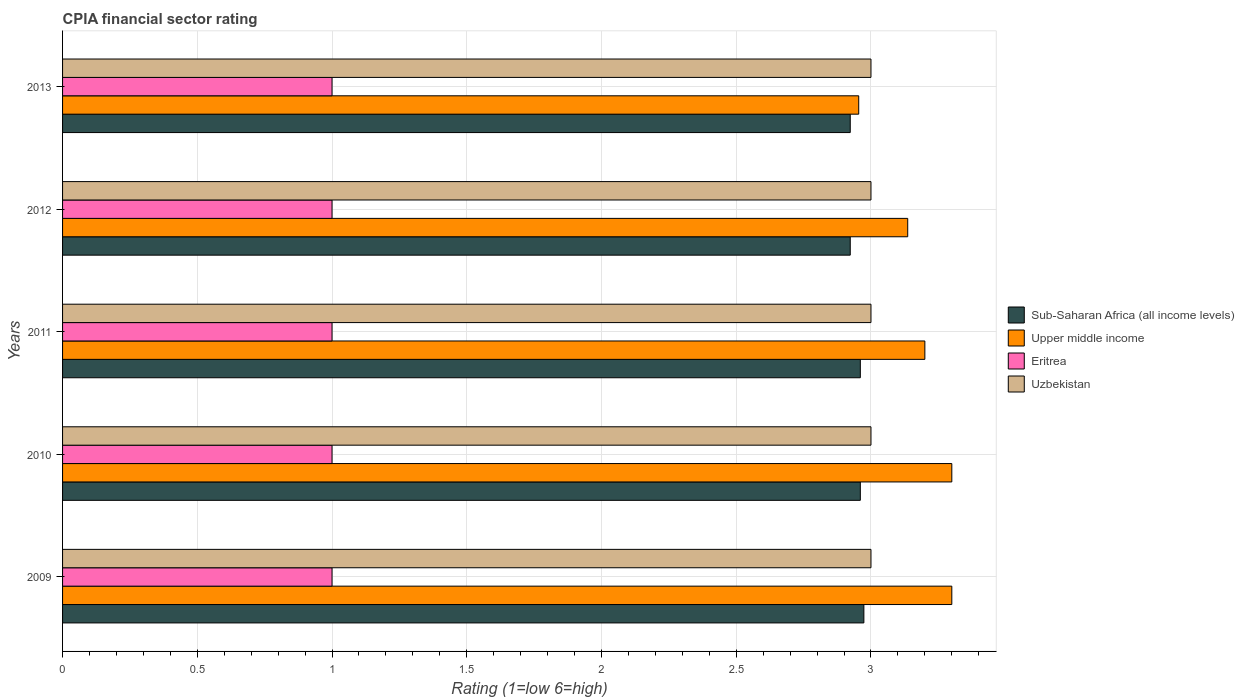How many different coloured bars are there?
Provide a short and direct response. 4. Are the number of bars per tick equal to the number of legend labels?
Keep it short and to the point. Yes. How many bars are there on the 3rd tick from the bottom?
Provide a succinct answer. 4. What is the CPIA rating in Eritrea in 2009?
Provide a short and direct response. 1. Across all years, what is the minimum CPIA rating in Sub-Saharan Africa (all income levels)?
Give a very brief answer. 2.92. In which year was the CPIA rating in Eritrea maximum?
Your answer should be compact. 2009. In which year was the CPIA rating in Uzbekistan minimum?
Offer a terse response. 2009. What is the total CPIA rating in Upper middle income in the graph?
Ensure brevity in your answer.  15.89. What is the difference between the CPIA rating in Uzbekistan in 2009 and the CPIA rating in Upper middle income in 2012?
Offer a terse response. -0.14. In the year 2010, what is the difference between the CPIA rating in Upper middle income and CPIA rating in Eritrea?
Provide a succinct answer. 2.3. In how many years, is the CPIA rating in Uzbekistan greater than 2.7 ?
Your answer should be very brief. 5. What is the ratio of the CPIA rating in Uzbekistan in 2010 to that in 2013?
Ensure brevity in your answer.  1. What is the difference between the highest and the second highest CPIA rating in Eritrea?
Keep it short and to the point. 0. In how many years, is the CPIA rating in Eritrea greater than the average CPIA rating in Eritrea taken over all years?
Make the answer very short. 0. Is the sum of the CPIA rating in Uzbekistan in 2011 and 2012 greater than the maximum CPIA rating in Eritrea across all years?
Offer a terse response. Yes. Is it the case that in every year, the sum of the CPIA rating in Eritrea and CPIA rating in Sub-Saharan Africa (all income levels) is greater than the sum of CPIA rating in Upper middle income and CPIA rating in Uzbekistan?
Your answer should be compact. Yes. What does the 4th bar from the top in 2013 represents?
Keep it short and to the point. Sub-Saharan Africa (all income levels). What does the 3rd bar from the bottom in 2010 represents?
Ensure brevity in your answer.  Eritrea. Are all the bars in the graph horizontal?
Provide a short and direct response. Yes. How many years are there in the graph?
Offer a terse response. 5. What is the difference between two consecutive major ticks on the X-axis?
Your response must be concise. 0.5. Are the values on the major ticks of X-axis written in scientific E-notation?
Provide a short and direct response. No. Does the graph contain any zero values?
Offer a terse response. No. Does the graph contain grids?
Your answer should be compact. Yes. What is the title of the graph?
Offer a terse response. CPIA financial sector rating. Does "Botswana" appear as one of the legend labels in the graph?
Make the answer very short. No. What is the label or title of the X-axis?
Provide a succinct answer. Rating (1=low 6=high). What is the label or title of the Y-axis?
Your answer should be very brief. Years. What is the Rating (1=low 6=high) in Sub-Saharan Africa (all income levels) in 2009?
Offer a very short reply. 2.97. What is the Rating (1=low 6=high) in Uzbekistan in 2009?
Your answer should be very brief. 3. What is the Rating (1=low 6=high) of Sub-Saharan Africa (all income levels) in 2010?
Give a very brief answer. 2.96. What is the Rating (1=low 6=high) in Upper middle income in 2010?
Keep it short and to the point. 3.3. What is the Rating (1=low 6=high) in Sub-Saharan Africa (all income levels) in 2011?
Offer a very short reply. 2.96. What is the Rating (1=low 6=high) of Upper middle income in 2011?
Provide a succinct answer. 3.2. What is the Rating (1=low 6=high) of Uzbekistan in 2011?
Ensure brevity in your answer.  3. What is the Rating (1=low 6=high) of Sub-Saharan Africa (all income levels) in 2012?
Offer a very short reply. 2.92. What is the Rating (1=low 6=high) of Upper middle income in 2012?
Ensure brevity in your answer.  3.14. What is the Rating (1=low 6=high) in Uzbekistan in 2012?
Keep it short and to the point. 3. What is the Rating (1=low 6=high) in Sub-Saharan Africa (all income levels) in 2013?
Give a very brief answer. 2.92. What is the Rating (1=low 6=high) in Upper middle income in 2013?
Offer a terse response. 2.95. What is the Rating (1=low 6=high) in Uzbekistan in 2013?
Give a very brief answer. 3. Across all years, what is the maximum Rating (1=low 6=high) of Sub-Saharan Africa (all income levels)?
Offer a terse response. 2.97. Across all years, what is the minimum Rating (1=low 6=high) in Sub-Saharan Africa (all income levels)?
Offer a very short reply. 2.92. Across all years, what is the minimum Rating (1=low 6=high) in Upper middle income?
Provide a short and direct response. 2.95. Across all years, what is the minimum Rating (1=low 6=high) in Eritrea?
Ensure brevity in your answer.  1. What is the total Rating (1=low 6=high) in Sub-Saharan Africa (all income levels) in the graph?
Your response must be concise. 14.74. What is the total Rating (1=low 6=high) of Upper middle income in the graph?
Keep it short and to the point. 15.89. What is the total Rating (1=low 6=high) of Uzbekistan in the graph?
Your answer should be very brief. 15. What is the difference between the Rating (1=low 6=high) in Sub-Saharan Africa (all income levels) in 2009 and that in 2010?
Give a very brief answer. 0.01. What is the difference between the Rating (1=low 6=high) of Upper middle income in 2009 and that in 2010?
Offer a terse response. 0. What is the difference between the Rating (1=low 6=high) in Eritrea in 2009 and that in 2010?
Offer a very short reply. 0. What is the difference between the Rating (1=low 6=high) in Sub-Saharan Africa (all income levels) in 2009 and that in 2011?
Make the answer very short. 0.01. What is the difference between the Rating (1=low 6=high) of Upper middle income in 2009 and that in 2011?
Ensure brevity in your answer.  0.1. What is the difference between the Rating (1=low 6=high) in Eritrea in 2009 and that in 2011?
Your answer should be compact. 0. What is the difference between the Rating (1=low 6=high) of Uzbekistan in 2009 and that in 2011?
Your response must be concise. 0. What is the difference between the Rating (1=low 6=high) in Sub-Saharan Africa (all income levels) in 2009 and that in 2012?
Offer a very short reply. 0.05. What is the difference between the Rating (1=low 6=high) of Upper middle income in 2009 and that in 2012?
Your answer should be very brief. 0.16. What is the difference between the Rating (1=low 6=high) of Uzbekistan in 2009 and that in 2012?
Your answer should be compact. 0. What is the difference between the Rating (1=low 6=high) in Sub-Saharan Africa (all income levels) in 2009 and that in 2013?
Keep it short and to the point. 0.05. What is the difference between the Rating (1=low 6=high) in Upper middle income in 2009 and that in 2013?
Ensure brevity in your answer.  0.35. What is the difference between the Rating (1=low 6=high) in Eritrea in 2009 and that in 2013?
Give a very brief answer. 0. What is the difference between the Rating (1=low 6=high) in Uzbekistan in 2009 and that in 2013?
Ensure brevity in your answer.  0. What is the difference between the Rating (1=low 6=high) of Upper middle income in 2010 and that in 2011?
Offer a very short reply. 0.1. What is the difference between the Rating (1=low 6=high) in Sub-Saharan Africa (all income levels) in 2010 and that in 2012?
Make the answer very short. 0.04. What is the difference between the Rating (1=low 6=high) of Upper middle income in 2010 and that in 2012?
Your answer should be compact. 0.16. What is the difference between the Rating (1=low 6=high) of Eritrea in 2010 and that in 2012?
Make the answer very short. 0. What is the difference between the Rating (1=low 6=high) in Sub-Saharan Africa (all income levels) in 2010 and that in 2013?
Your answer should be very brief. 0.04. What is the difference between the Rating (1=low 6=high) in Upper middle income in 2010 and that in 2013?
Ensure brevity in your answer.  0.35. What is the difference between the Rating (1=low 6=high) in Eritrea in 2010 and that in 2013?
Your response must be concise. 0. What is the difference between the Rating (1=low 6=high) in Sub-Saharan Africa (all income levels) in 2011 and that in 2012?
Keep it short and to the point. 0.04. What is the difference between the Rating (1=low 6=high) in Upper middle income in 2011 and that in 2012?
Offer a very short reply. 0.06. What is the difference between the Rating (1=low 6=high) of Eritrea in 2011 and that in 2012?
Provide a short and direct response. 0. What is the difference between the Rating (1=low 6=high) of Uzbekistan in 2011 and that in 2012?
Your response must be concise. 0. What is the difference between the Rating (1=low 6=high) in Sub-Saharan Africa (all income levels) in 2011 and that in 2013?
Offer a very short reply. 0.04. What is the difference between the Rating (1=low 6=high) of Upper middle income in 2011 and that in 2013?
Give a very brief answer. 0.25. What is the difference between the Rating (1=low 6=high) of Eritrea in 2011 and that in 2013?
Offer a terse response. 0. What is the difference between the Rating (1=low 6=high) in Uzbekistan in 2011 and that in 2013?
Give a very brief answer. 0. What is the difference between the Rating (1=low 6=high) of Sub-Saharan Africa (all income levels) in 2012 and that in 2013?
Offer a terse response. 0. What is the difference between the Rating (1=low 6=high) of Upper middle income in 2012 and that in 2013?
Your answer should be compact. 0.18. What is the difference between the Rating (1=low 6=high) of Eritrea in 2012 and that in 2013?
Offer a terse response. 0. What is the difference between the Rating (1=low 6=high) of Sub-Saharan Africa (all income levels) in 2009 and the Rating (1=low 6=high) of Upper middle income in 2010?
Make the answer very short. -0.33. What is the difference between the Rating (1=low 6=high) in Sub-Saharan Africa (all income levels) in 2009 and the Rating (1=low 6=high) in Eritrea in 2010?
Keep it short and to the point. 1.97. What is the difference between the Rating (1=low 6=high) in Sub-Saharan Africa (all income levels) in 2009 and the Rating (1=low 6=high) in Uzbekistan in 2010?
Give a very brief answer. -0.03. What is the difference between the Rating (1=low 6=high) in Sub-Saharan Africa (all income levels) in 2009 and the Rating (1=low 6=high) in Upper middle income in 2011?
Your response must be concise. -0.23. What is the difference between the Rating (1=low 6=high) of Sub-Saharan Africa (all income levels) in 2009 and the Rating (1=low 6=high) of Eritrea in 2011?
Offer a terse response. 1.97. What is the difference between the Rating (1=low 6=high) in Sub-Saharan Africa (all income levels) in 2009 and the Rating (1=low 6=high) in Uzbekistan in 2011?
Make the answer very short. -0.03. What is the difference between the Rating (1=low 6=high) in Upper middle income in 2009 and the Rating (1=low 6=high) in Eritrea in 2011?
Offer a very short reply. 2.3. What is the difference between the Rating (1=low 6=high) of Sub-Saharan Africa (all income levels) in 2009 and the Rating (1=low 6=high) of Upper middle income in 2012?
Your answer should be compact. -0.16. What is the difference between the Rating (1=low 6=high) in Sub-Saharan Africa (all income levels) in 2009 and the Rating (1=low 6=high) in Eritrea in 2012?
Your answer should be very brief. 1.97. What is the difference between the Rating (1=low 6=high) in Sub-Saharan Africa (all income levels) in 2009 and the Rating (1=low 6=high) in Uzbekistan in 2012?
Your answer should be very brief. -0.03. What is the difference between the Rating (1=low 6=high) in Eritrea in 2009 and the Rating (1=low 6=high) in Uzbekistan in 2012?
Give a very brief answer. -2. What is the difference between the Rating (1=low 6=high) of Sub-Saharan Africa (all income levels) in 2009 and the Rating (1=low 6=high) of Upper middle income in 2013?
Your answer should be very brief. 0.02. What is the difference between the Rating (1=low 6=high) in Sub-Saharan Africa (all income levels) in 2009 and the Rating (1=low 6=high) in Eritrea in 2013?
Your answer should be very brief. 1.97. What is the difference between the Rating (1=low 6=high) in Sub-Saharan Africa (all income levels) in 2009 and the Rating (1=low 6=high) in Uzbekistan in 2013?
Keep it short and to the point. -0.03. What is the difference between the Rating (1=low 6=high) of Upper middle income in 2009 and the Rating (1=low 6=high) of Uzbekistan in 2013?
Your response must be concise. 0.3. What is the difference between the Rating (1=low 6=high) in Eritrea in 2009 and the Rating (1=low 6=high) in Uzbekistan in 2013?
Provide a short and direct response. -2. What is the difference between the Rating (1=low 6=high) in Sub-Saharan Africa (all income levels) in 2010 and the Rating (1=low 6=high) in Upper middle income in 2011?
Give a very brief answer. -0.24. What is the difference between the Rating (1=low 6=high) of Sub-Saharan Africa (all income levels) in 2010 and the Rating (1=low 6=high) of Eritrea in 2011?
Your answer should be compact. 1.96. What is the difference between the Rating (1=low 6=high) in Sub-Saharan Africa (all income levels) in 2010 and the Rating (1=low 6=high) in Uzbekistan in 2011?
Provide a succinct answer. -0.04. What is the difference between the Rating (1=low 6=high) in Sub-Saharan Africa (all income levels) in 2010 and the Rating (1=low 6=high) in Upper middle income in 2012?
Provide a succinct answer. -0.18. What is the difference between the Rating (1=low 6=high) of Sub-Saharan Africa (all income levels) in 2010 and the Rating (1=low 6=high) of Eritrea in 2012?
Your answer should be compact. 1.96. What is the difference between the Rating (1=low 6=high) of Sub-Saharan Africa (all income levels) in 2010 and the Rating (1=low 6=high) of Uzbekistan in 2012?
Provide a succinct answer. -0.04. What is the difference between the Rating (1=low 6=high) in Upper middle income in 2010 and the Rating (1=low 6=high) in Eritrea in 2012?
Keep it short and to the point. 2.3. What is the difference between the Rating (1=low 6=high) in Upper middle income in 2010 and the Rating (1=low 6=high) in Uzbekistan in 2012?
Offer a terse response. 0.3. What is the difference between the Rating (1=low 6=high) of Eritrea in 2010 and the Rating (1=low 6=high) of Uzbekistan in 2012?
Keep it short and to the point. -2. What is the difference between the Rating (1=low 6=high) in Sub-Saharan Africa (all income levels) in 2010 and the Rating (1=low 6=high) in Upper middle income in 2013?
Provide a short and direct response. 0.01. What is the difference between the Rating (1=low 6=high) in Sub-Saharan Africa (all income levels) in 2010 and the Rating (1=low 6=high) in Eritrea in 2013?
Your response must be concise. 1.96. What is the difference between the Rating (1=low 6=high) in Sub-Saharan Africa (all income levels) in 2010 and the Rating (1=low 6=high) in Uzbekistan in 2013?
Your answer should be very brief. -0.04. What is the difference between the Rating (1=low 6=high) in Upper middle income in 2010 and the Rating (1=low 6=high) in Eritrea in 2013?
Give a very brief answer. 2.3. What is the difference between the Rating (1=low 6=high) of Eritrea in 2010 and the Rating (1=low 6=high) of Uzbekistan in 2013?
Ensure brevity in your answer.  -2. What is the difference between the Rating (1=low 6=high) in Sub-Saharan Africa (all income levels) in 2011 and the Rating (1=low 6=high) in Upper middle income in 2012?
Keep it short and to the point. -0.18. What is the difference between the Rating (1=low 6=high) of Sub-Saharan Africa (all income levels) in 2011 and the Rating (1=low 6=high) of Eritrea in 2012?
Give a very brief answer. 1.96. What is the difference between the Rating (1=low 6=high) in Sub-Saharan Africa (all income levels) in 2011 and the Rating (1=low 6=high) in Uzbekistan in 2012?
Keep it short and to the point. -0.04. What is the difference between the Rating (1=low 6=high) in Upper middle income in 2011 and the Rating (1=low 6=high) in Eritrea in 2012?
Give a very brief answer. 2.2. What is the difference between the Rating (1=low 6=high) of Upper middle income in 2011 and the Rating (1=low 6=high) of Uzbekistan in 2012?
Provide a succinct answer. 0.2. What is the difference between the Rating (1=low 6=high) in Sub-Saharan Africa (all income levels) in 2011 and the Rating (1=low 6=high) in Upper middle income in 2013?
Provide a succinct answer. 0.01. What is the difference between the Rating (1=low 6=high) in Sub-Saharan Africa (all income levels) in 2011 and the Rating (1=low 6=high) in Eritrea in 2013?
Your answer should be compact. 1.96. What is the difference between the Rating (1=low 6=high) in Sub-Saharan Africa (all income levels) in 2011 and the Rating (1=low 6=high) in Uzbekistan in 2013?
Make the answer very short. -0.04. What is the difference between the Rating (1=low 6=high) of Sub-Saharan Africa (all income levels) in 2012 and the Rating (1=low 6=high) of Upper middle income in 2013?
Keep it short and to the point. -0.03. What is the difference between the Rating (1=low 6=high) in Sub-Saharan Africa (all income levels) in 2012 and the Rating (1=low 6=high) in Eritrea in 2013?
Your answer should be compact. 1.92. What is the difference between the Rating (1=low 6=high) of Sub-Saharan Africa (all income levels) in 2012 and the Rating (1=low 6=high) of Uzbekistan in 2013?
Provide a short and direct response. -0.08. What is the difference between the Rating (1=low 6=high) in Upper middle income in 2012 and the Rating (1=low 6=high) in Eritrea in 2013?
Your response must be concise. 2.14. What is the difference between the Rating (1=low 6=high) of Upper middle income in 2012 and the Rating (1=low 6=high) of Uzbekistan in 2013?
Offer a terse response. 0.14. What is the difference between the Rating (1=low 6=high) in Eritrea in 2012 and the Rating (1=low 6=high) in Uzbekistan in 2013?
Your answer should be very brief. -2. What is the average Rating (1=low 6=high) in Sub-Saharan Africa (all income levels) per year?
Ensure brevity in your answer.  2.95. What is the average Rating (1=low 6=high) in Upper middle income per year?
Keep it short and to the point. 3.18. What is the average Rating (1=low 6=high) of Eritrea per year?
Your response must be concise. 1. In the year 2009, what is the difference between the Rating (1=low 6=high) of Sub-Saharan Africa (all income levels) and Rating (1=low 6=high) of Upper middle income?
Make the answer very short. -0.33. In the year 2009, what is the difference between the Rating (1=low 6=high) in Sub-Saharan Africa (all income levels) and Rating (1=low 6=high) in Eritrea?
Make the answer very short. 1.97. In the year 2009, what is the difference between the Rating (1=low 6=high) in Sub-Saharan Africa (all income levels) and Rating (1=low 6=high) in Uzbekistan?
Offer a very short reply. -0.03. In the year 2010, what is the difference between the Rating (1=low 6=high) of Sub-Saharan Africa (all income levels) and Rating (1=low 6=high) of Upper middle income?
Provide a short and direct response. -0.34. In the year 2010, what is the difference between the Rating (1=low 6=high) in Sub-Saharan Africa (all income levels) and Rating (1=low 6=high) in Eritrea?
Keep it short and to the point. 1.96. In the year 2010, what is the difference between the Rating (1=low 6=high) of Sub-Saharan Africa (all income levels) and Rating (1=low 6=high) of Uzbekistan?
Give a very brief answer. -0.04. In the year 2010, what is the difference between the Rating (1=low 6=high) in Upper middle income and Rating (1=low 6=high) in Uzbekistan?
Your answer should be compact. 0.3. In the year 2010, what is the difference between the Rating (1=low 6=high) in Eritrea and Rating (1=low 6=high) in Uzbekistan?
Your response must be concise. -2. In the year 2011, what is the difference between the Rating (1=low 6=high) in Sub-Saharan Africa (all income levels) and Rating (1=low 6=high) in Upper middle income?
Offer a very short reply. -0.24. In the year 2011, what is the difference between the Rating (1=low 6=high) of Sub-Saharan Africa (all income levels) and Rating (1=low 6=high) of Eritrea?
Make the answer very short. 1.96. In the year 2011, what is the difference between the Rating (1=low 6=high) of Sub-Saharan Africa (all income levels) and Rating (1=low 6=high) of Uzbekistan?
Give a very brief answer. -0.04. In the year 2011, what is the difference between the Rating (1=low 6=high) in Upper middle income and Rating (1=low 6=high) in Uzbekistan?
Provide a succinct answer. 0.2. In the year 2011, what is the difference between the Rating (1=low 6=high) of Eritrea and Rating (1=low 6=high) of Uzbekistan?
Your response must be concise. -2. In the year 2012, what is the difference between the Rating (1=low 6=high) in Sub-Saharan Africa (all income levels) and Rating (1=low 6=high) in Upper middle income?
Offer a very short reply. -0.21. In the year 2012, what is the difference between the Rating (1=low 6=high) of Sub-Saharan Africa (all income levels) and Rating (1=low 6=high) of Eritrea?
Your answer should be compact. 1.92. In the year 2012, what is the difference between the Rating (1=low 6=high) of Sub-Saharan Africa (all income levels) and Rating (1=low 6=high) of Uzbekistan?
Provide a short and direct response. -0.08. In the year 2012, what is the difference between the Rating (1=low 6=high) of Upper middle income and Rating (1=low 6=high) of Eritrea?
Give a very brief answer. 2.14. In the year 2012, what is the difference between the Rating (1=low 6=high) of Upper middle income and Rating (1=low 6=high) of Uzbekistan?
Your answer should be very brief. 0.14. In the year 2012, what is the difference between the Rating (1=low 6=high) in Eritrea and Rating (1=low 6=high) in Uzbekistan?
Provide a succinct answer. -2. In the year 2013, what is the difference between the Rating (1=low 6=high) in Sub-Saharan Africa (all income levels) and Rating (1=low 6=high) in Upper middle income?
Make the answer very short. -0.03. In the year 2013, what is the difference between the Rating (1=low 6=high) in Sub-Saharan Africa (all income levels) and Rating (1=low 6=high) in Eritrea?
Your answer should be very brief. 1.92. In the year 2013, what is the difference between the Rating (1=low 6=high) in Sub-Saharan Africa (all income levels) and Rating (1=low 6=high) in Uzbekistan?
Ensure brevity in your answer.  -0.08. In the year 2013, what is the difference between the Rating (1=low 6=high) of Upper middle income and Rating (1=low 6=high) of Eritrea?
Ensure brevity in your answer.  1.95. In the year 2013, what is the difference between the Rating (1=low 6=high) of Upper middle income and Rating (1=low 6=high) of Uzbekistan?
Your answer should be compact. -0.05. What is the ratio of the Rating (1=low 6=high) in Eritrea in 2009 to that in 2010?
Your response must be concise. 1. What is the ratio of the Rating (1=low 6=high) in Upper middle income in 2009 to that in 2011?
Provide a short and direct response. 1.03. What is the ratio of the Rating (1=low 6=high) in Sub-Saharan Africa (all income levels) in 2009 to that in 2012?
Ensure brevity in your answer.  1.02. What is the ratio of the Rating (1=low 6=high) in Upper middle income in 2009 to that in 2012?
Your answer should be very brief. 1.05. What is the ratio of the Rating (1=low 6=high) of Uzbekistan in 2009 to that in 2012?
Make the answer very short. 1. What is the ratio of the Rating (1=low 6=high) of Sub-Saharan Africa (all income levels) in 2009 to that in 2013?
Make the answer very short. 1.02. What is the ratio of the Rating (1=low 6=high) in Upper middle income in 2009 to that in 2013?
Keep it short and to the point. 1.12. What is the ratio of the Rating (1=low 6=high) of Sub-Saharan Africa (all income levels) in 2010 to that in 2011?
Your response must be concise. 1. What is the ratio of the Rating (1=low 6=high) of Upper middle income in 2010 to that in 2011?
Give a very brief answer. 1.03. What is the ratio of the Rating (1=low 6=high) of Eritrea in 2010 to that in 2011?
Provide a short and direct response. 1. What is the ratio of the Rating (1=low 6=high) of Sub-Saharan Africa (all income levels) in 2010 to that in 2012?
Offer a terse response. 1.01. What is the ratio of the Rating (1=low 6=high) in Upper middle income in 2010 to that in 2012?
Make the answer very short. 1.05. What is the ratio of the Rating (1=low 6=high) of Uzbekistan in 2010 to that in 2012?
Your answer should be very brief. 1. What is the ratio of the Rating (1=low 6=high) of Sub-Saharan Africa (all income levels) in 2010 to that in 2013?
Keep it short and to the point. 1.01. What is the ratio of the Rating (1=low 6=high) in Upper middle income in 2010 to that in 2013?
Your answer should be compact. 1.12. What is the ratio of the Rating (1=low 6=high) in Eritrea in 2010 to that in 2013?
Your response must be concise. 1. What is the ratio of the Rating (1=low 6=high) in Uzbekistan in 2010 to that in 2013?
Your answer should be very brief. 1. What is the ratio of the Rating (1=low 6=high) in Sub-Saharan Africa (all income levels) in 2011 to that in 2012?
Keep it short and to the point. 1.01. What is the ratio of the Rating (1=low 6=high) of Upper middle income in 2011 to that in 2012?
Your answer should be compact. 1.02. What is the ratio of the Rating (1=low 6=high) of Sub-Saharan Africa (all income levels) in 2011 to that in 2013?
Offer a very short reply. 1.01. What is the ratio of the Rating (1=low 6=high) of Upper middle income in 2011 to that in 2013?
Your answer should be compact. 1.08. What is the ratio of the Rating (1=low 6=high) of Uzbekistan in 2011 to that in 2013?
Your answer should be compact. 1. What is the ratio of the Rating (1=low 6=high) of Upper middle income in 2012 to that in 2013?
Make the answer very short. 1.06. What is the ratio of the Rating (1=low 6=high) in Eritrea in 2012 to that in 2013?
Make the answer very short. 1. What is the difference between the highest and the second highest Rating (1=low 6=high) of Sub-Saharan Africa (all income levels)?
Ensure brevity in your answer.  0.01. What is the difference between the highest and the second highest Rating (1=low 6=high) of Eritrea?
Provide a succinct answer. 0. What is the difference between the highest and the second highest Rating (1=low 6=high) of Uzbekistan?
Provide a short and direct response. 0. What is the difference between the highest and the lowest Rating (1=low 6=high) in Sub-Saharan Africa (all income levels)?
Provide a short and direct response. 0.05. What is the difference between the highest and the lowest Rating (1=low 6=high) in Upper middle income?
Provide a succinct answer. 0.35. What is the difference between the highest and the lowest Rating (1=low 6=high) of Eritrea?
Provide a short and direct response. 0. 